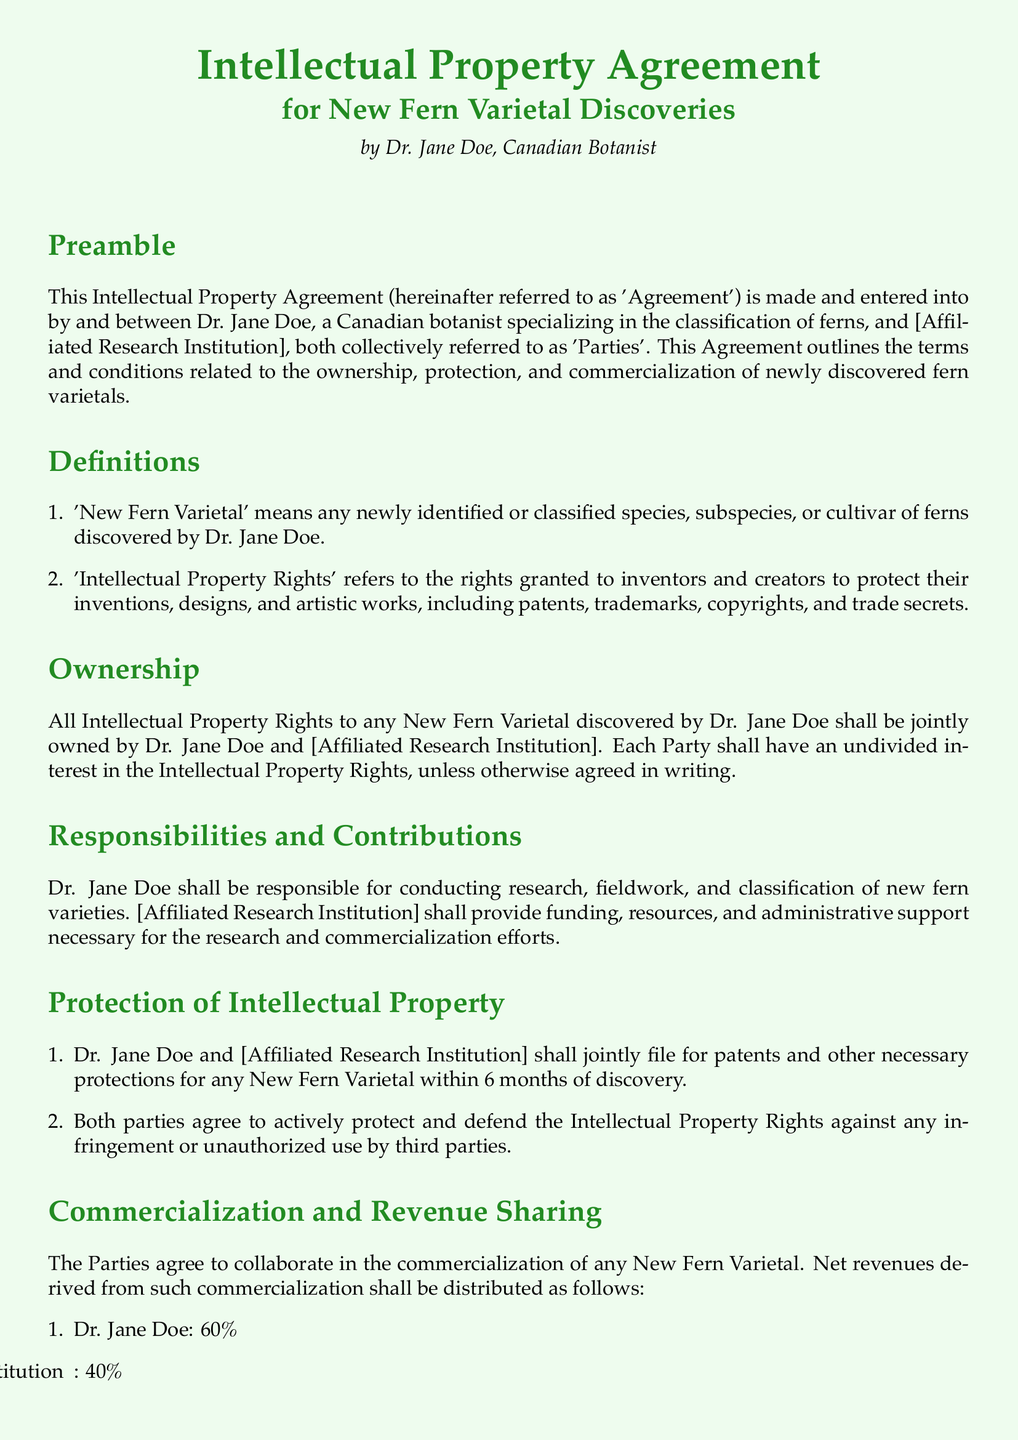What is the name of the Agreement? The name is stated in the title of the document, which is "Intellectual Property Agreement".
Answer: Intellectual Property Agreement Who is the author of the Agreement? The author is specified in the document as Dr. Jane Doe, Canadian Botanist.
Answer: Dr. Jane Doe What percentage of revenue goes to Dr. Jane Doe? The document outlines a revenue-sharing agreement, where Dr. Jane Doe receives 60%.
Answer: 60% What is the duration of the confidentiality obligation? The document specifies that confidential information must be kept confidential indefinitely unless consent is provided, but this is implied rather than explicitly stated.
Answer: Indefinitely Which party is responsible for research and classification? The responsibilities of Dr. Jane Doe are outlined, emphasizing her role in research and classification.
Answer: Dr. Jane Doe What is the governing law for this Agreement? The document states that the Agreement is governed by the laws of the Province of British Columbia, Canada.
Answer: British Columbia How many days notice is required for termination? The document specifies a notice period of 60 days for termination of the Agreement.
Answer: 60 days What will happen if one party terminates the Agreement? The document states that either party may terminate the Agreement with written notice, and there are no additional obligations mentioned upon termination.
Answer: Written notice What is considered a 'New Fern Varietal'? The document defines a 'New Fern Varietal' as any newly identified or classified species, subspecies, or cultivar of ferns discovered by Dr. Jane Doe.
Answer: Any newly identified or classified species, subspecies, or cultivar of ferns discovered by Dr. Jane Doe 